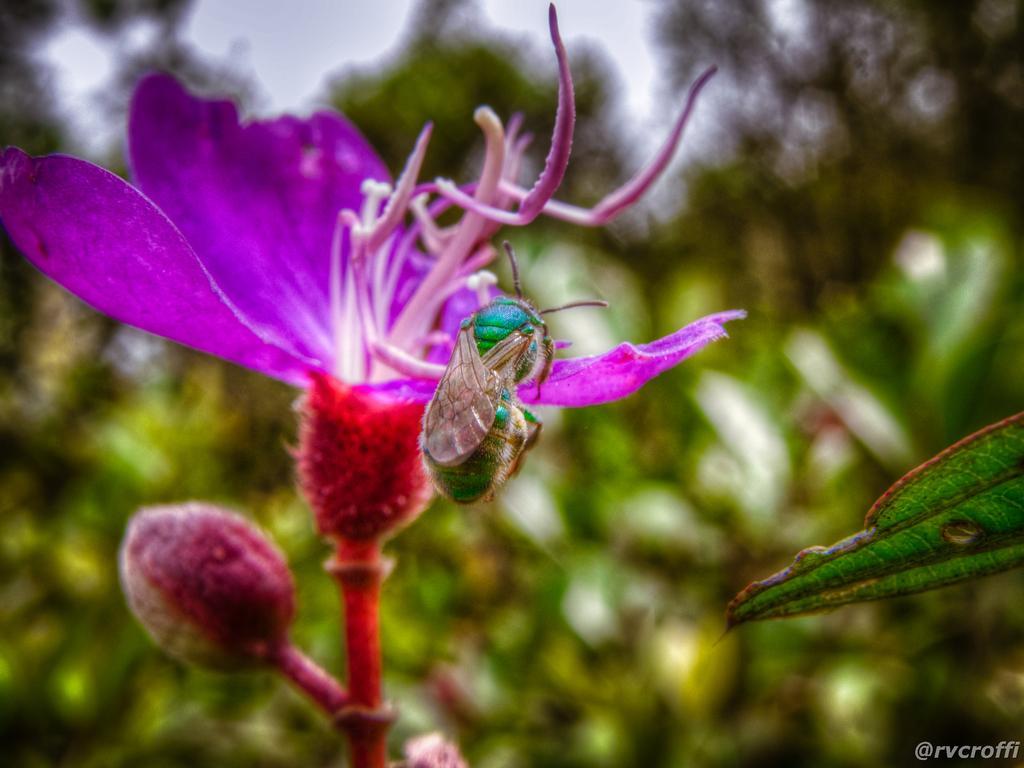Could you give a brief overview of what you see in this image? In the image we can see a flower, purple and red in color. On the flower there is an insect. There is a watermark at the right bottom corner and the background is blurred. 